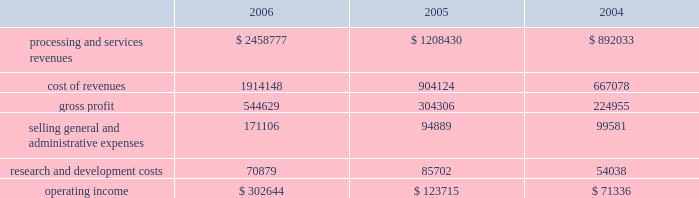Higher average borrowings .
Additionally , the recapitalization that occurred late in the first quarter of 2005 resulted in a full year of interest in 2006 as compared to approximately ten months in 2005 .
The increase in interest expense in 2005 as compared to 2004 also resulted from the recapitalization in 2005 .
Income tax expense income tax expense totaled $ 150.2 million , $ 116.1 million and $ 118.3 million for 2006 , 2005 and 2004 , respectively .
This resulted in an effective tax rate of 37.2% ( 37.2 % ) , 37.2% ( 37.2 % ) and 37.6% ( 37.6 % ) for 2006 , 2005 and 2004 , respectively .
Net earnings net earnings totaled $ 259.1 million , $ 196.6 and $ 189.4 million for 2006 , 2005 and 2004 , respectively , or $ 1.37 , $ 1.53 and $ 1.48 per diluted share , respectively .
Segment results of operations transaction processing services ( in thousands ) .
Revenues for the transaction processing services segment are derived from three main revenue channels ; enterprise solutions , integrated financial solutions and international .
Revenues from transaction processing services totaled $ 2458.8 million , $ 1208.4 and $ 892.0 million for 2006 , 2005 and 2004 , respectively .
The overall segment increase of $ 1250.4 million during 2006 , as compared to 2005 was primarily attributable to the certegy merger which contributed $ 1067.2 million to the overall increase .
The majority of the remaining 2006 growth is attributable to organic growth within the historically owned integrated financial solutions and international revenue channels , with international including $ 31.9 million related to the newly formed business process outsourcing operation in brazil .
The overall segment increase of $ 316.4 in 2005 as compared to 2004 results from the inclusion of a full year of results for the 2004 acquisitions of aurum , sanchez , kordoba , and intercept , which contributed $ 301.1 million of the increase .
Cost of revenues for the transaction processing services segment totaled $ 1914.1 million , $ 904.1 million and $ 667.1 million for 2006 , 2005 and 2004 , respectively .
The overall segment increase of $ 1010.0 million during 2006 as compared to 2005 was primarily attributable to the certegy merger which contributed $ 848.2 million to the increase .
Gross profit as a percentage of revenues ( 201cgross margin 201d ) was 22.2% ( 22.2 % ) , 25.2% ( 25.2 % ) and 25.2% ( 25.2 % ) for 2006 , 2005 and 2004 , respectively .
The decrease in gross profit in 2006 as compared to 2005 is primarily due to the february 1 , 2006 certegy merger , which businesses typically have lower margins than those of the historically owned fis businesses .
Incremental intangible asset amortization relating to the certegy merger also contributed to the decrease in gross margin .
Included in cost of revenues was depreciation and amortization of $ 272.4 million , $ 139.8 million , and $ 94.6 million for 2006 , 2005 and 2004 , respectively .
Selling , general and administrative expenses totaled $ 171.1 million , $ 94.9 million and $ 99.6 million for 2006 , 2005 and 2004 , respectively .
The increase in 2006 compared to 2005 is primarily attributable to the certegy merger which contributed $ 73.7 million to the overall increase of $ 76.2 million .
The decrease of $ 4.7 million in 2005 as compared to 2004 is primarily attributable to the effect of acquisition related costs in 2004 .
Included in selling , general and administrative expenses was depreciation and amortization of $ 11.0 million , $ 9.1 million and $ 2.3 million for 2006 , 2005 and 2004 , respectively. .
What is the gross profit margin for 2006? 
Computations: (544629 / 2458777)
Answer: 0.2215. 